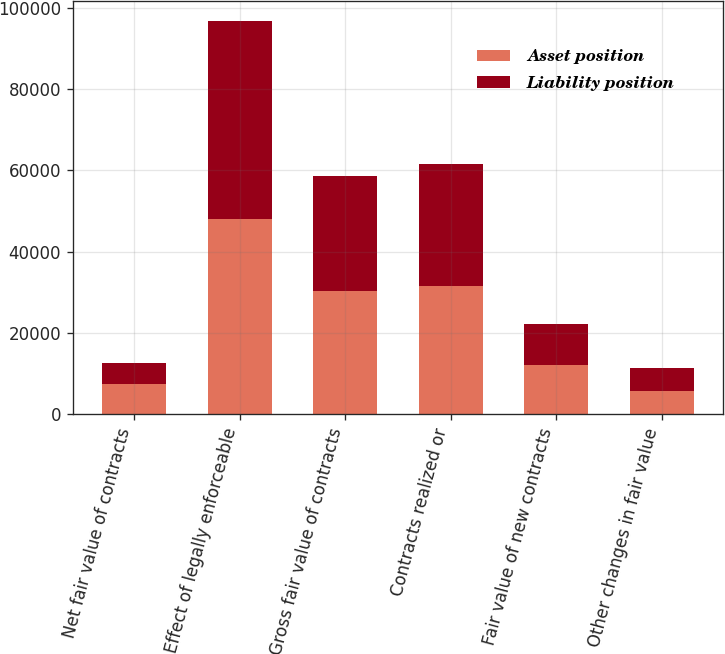Convert chart to OTSL. <chart><loc_0><loc_0><loc_500><loc_500><stacked_bar_chart><ecel><fcel>Net fair value of contracts<fcel>Effect of legally enforceable<fcel>Gross fair value of contracts<fcel>Contracts realized or<fcel>Fair value of new contracts<fcel>Other changes in fair value<nl><fcel>Asset position<fcel>7432<fcel>48091<fcel>30309<fcel>31444<fcel>12050<fcel>5820<nl><fcel>Liability position<fcel>5139<fcel>48726<fcel>28227<fcel>30248<fcel>10192<fcel>5582<nl></chart> 